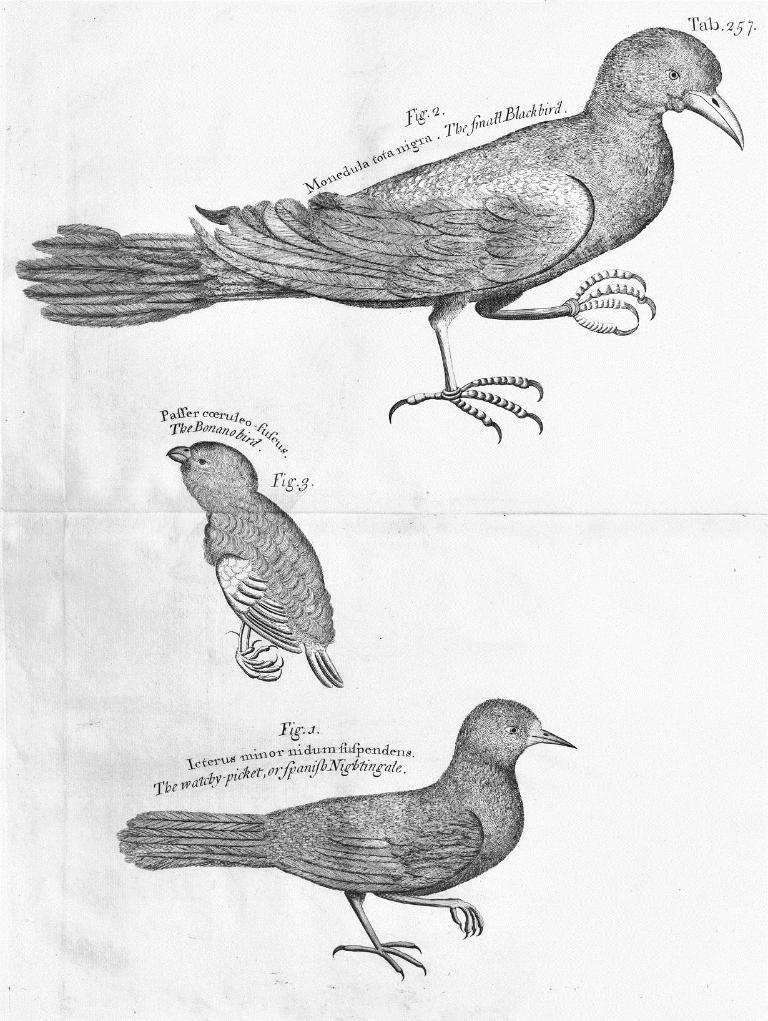What is present on the paper in the image? The paper contains a design of three birds and some quotations. Can you describe the design on the paper? The design on the paper features three birds. What else can be found on the paper besides the bird design? There are quotations on the paper. How many bells are hanging in the room depicted in the image? There are no bells or rooms depicted in the image; it only features a paper with a bird design and quotations. 